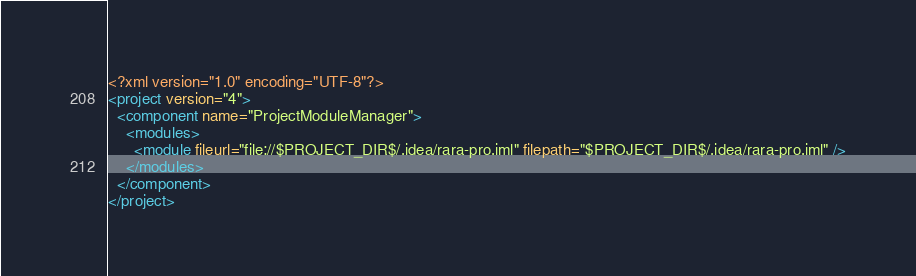Convert code to text. <code><loc_0><loc_0><loc_500><loc_500><_XML_><?xml version="1.0" encoding="UTF-8"?>
<project version="4">
  <component name="ProjectModuleManager">
    <modules>
      <module fileurl="file://$PROJECT_DIR$/.idea/rara-pro.iml" filepath="$PROJECT_DIR$/.idea/rara-pro.iml" />
    </modules>
  </component>
</project></code> 